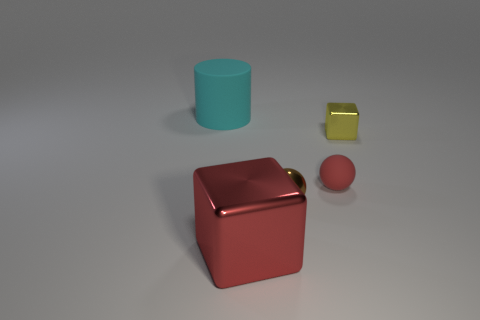Add 2 red metallic balls. How many objects exist? 7 Subtract all blocks. How many objects are left? 3 Subtract 1 red balls. How many objects are left? 4 Subtract all small brown objects. Subtract all tiny metal cubes. How many objects are left? 3 Add 2 big matte cylinders. How many big matte cylinders are left? 3 Add 3 matte things. How many matte things exist? 5 